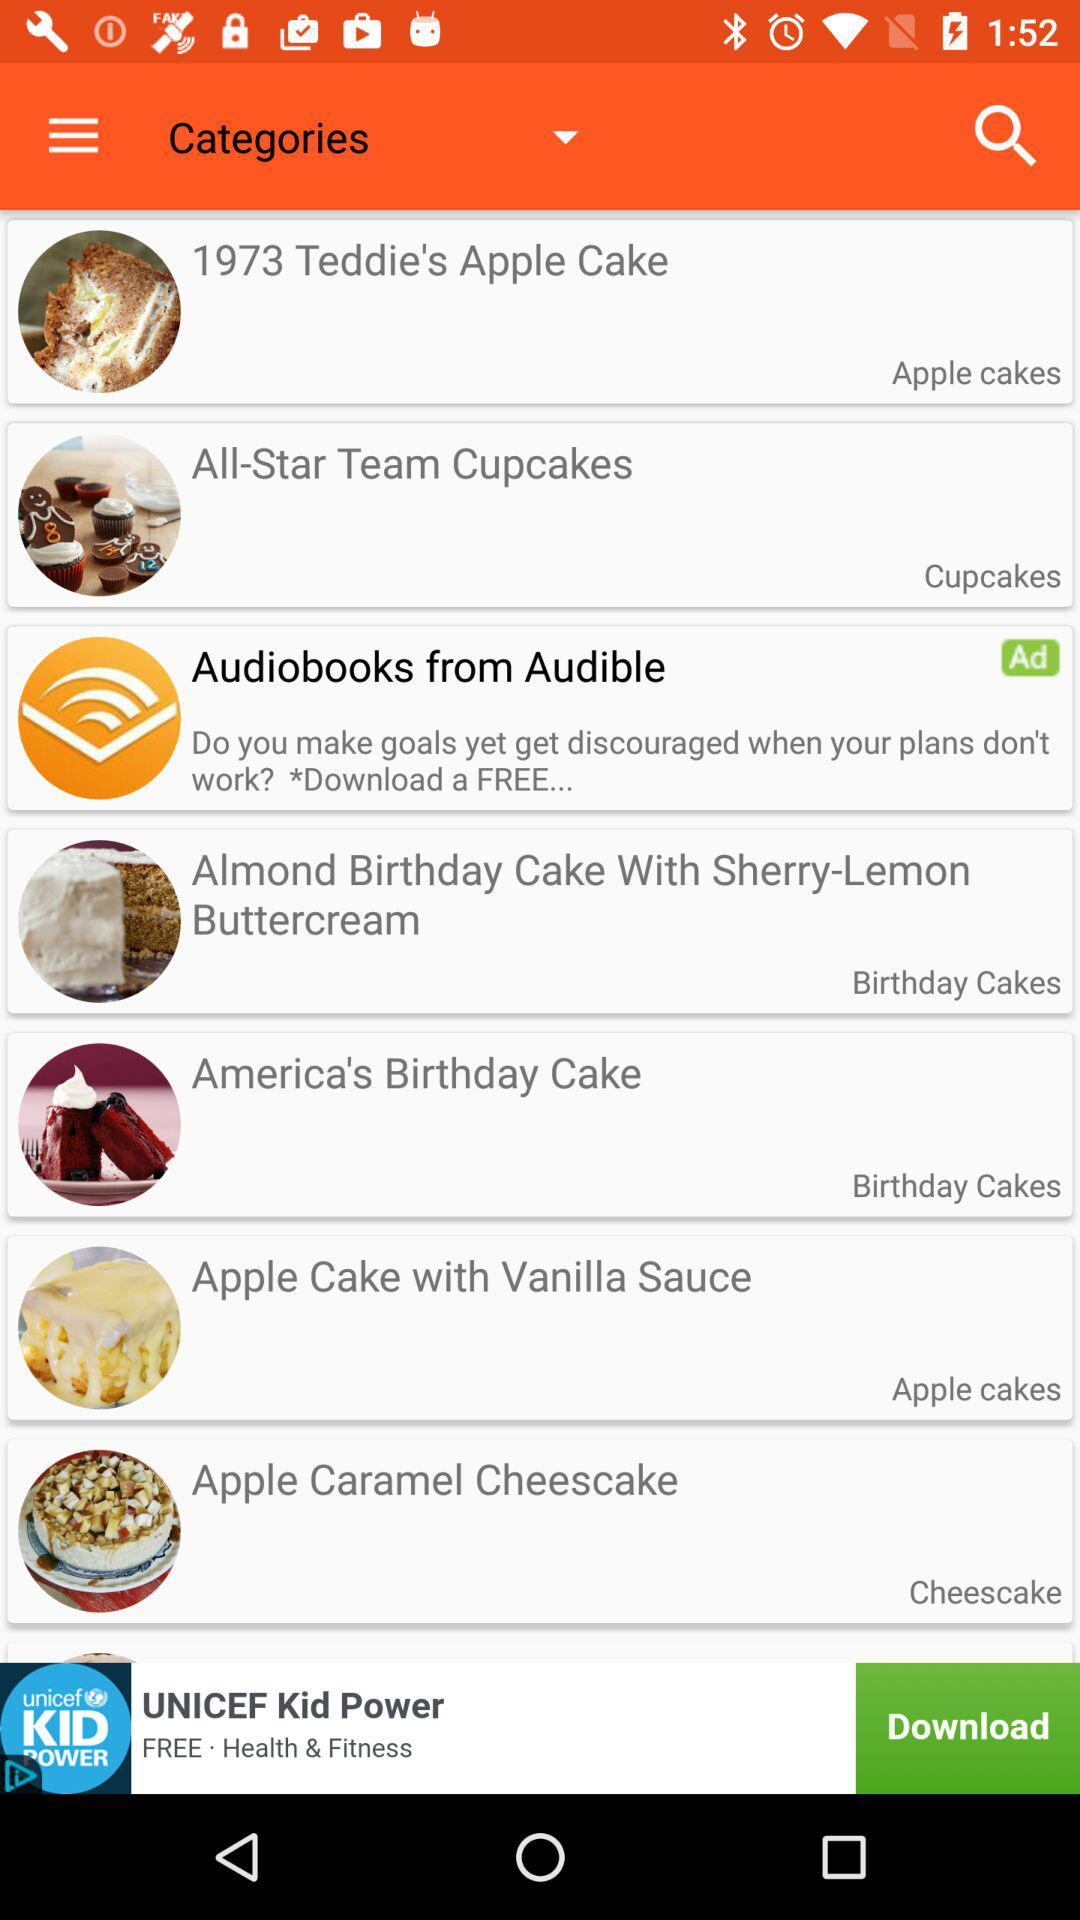What is the name of the cupcake store? The name is "All-Star Team Cupcakes". 